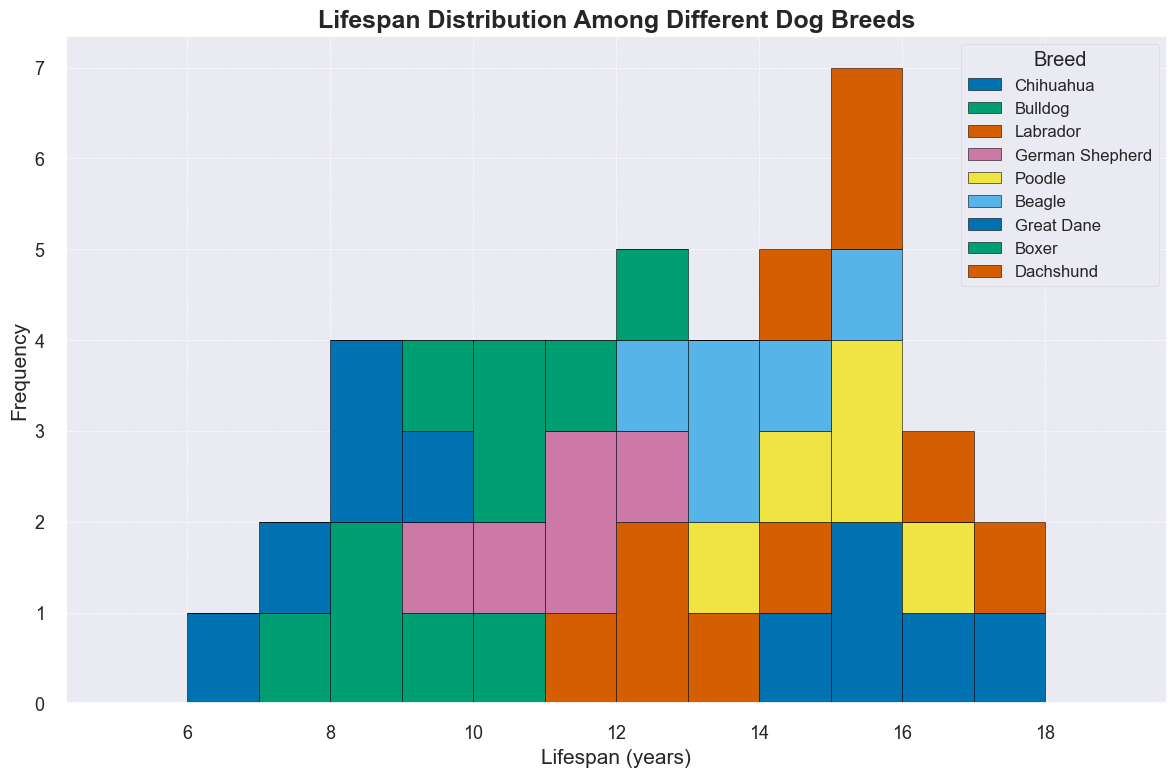Which breed has the highest lifespan observed in the histogram? The histogram shows the lifespan distribution of different breeds. Based on the data, the highest lifespan observed is for the Chihuahua and Dachshund breeds, both reaching up to 17 years.
Answer: Chihuahua and Dachshund Which breed shows the most varied lifespan in the histogram? Varied lifespan can be interpreted by the range of years shown in the histogram. Bulldogs and Great Danes have lifespans ranging from 6 to 10 years, thus showing the greatest variation.
Answer: Bulldogs and Great Danes What's the average lifespan of a German Shepherd according to the histogram? To find the average lifespan, sum the lifespans of German Shepherds and divide by the number of observations. (10 + 12 + 11 + 9 + 11) = 53. So, 53/5 = 10.6 years.
Answer: 10.6 years Which breed has a lower lifespan, Bulldogs or Boxers? By comparing the ranges in the histogram, Bulldogs have lifespans between 7-10 years while Boxers have lifespans between 9-12 years. Hence, Bulldogs have a lower lifespan.
Answer: Bulldogs How many breeds have their maximum frequency at a lifespan of 15 years? Examining the peaks of each histogram segment, Chihuahuas, Poodles, Beagles, and Dachshunds have their highest frequency at 15 years.
Answer: 4 breeds Which breed has the shortest lifespan according to the histogram? The shortest lifespan should be the minimum value among all breeds. Observing the histogram, it's evident that Great Danes have the shortest lifespan at 6 years.
Answer: Great Danes How does the lifespan range of Labradors compare to Poodles? Labradors have lifespans ranging from 11 to 14 years, whereas Poodles range from 13 to 16 years. Poodles generally live longer than Labradors.
Answer: Poodles live longer Among Chihuahuas, Bulldogs, and Boxers, which breed shows more consistency in their lifespan? Consistency can be evaluated by the range and frequency of lifespan values. Chihuahuas range from 14 to 17 years, Boxers from 9 to 12 years, and Bulldogs from 7 to 10 years. Chihuahuas have the smallest range, indicating more consistency.
Answer: Chihuahuas What is the most common lifespan for Beagles in the histogram? Observing the histogram bars for Beagles, the mode (most frequently occurring lifespan) is 13 years.
Answer: 13 years 